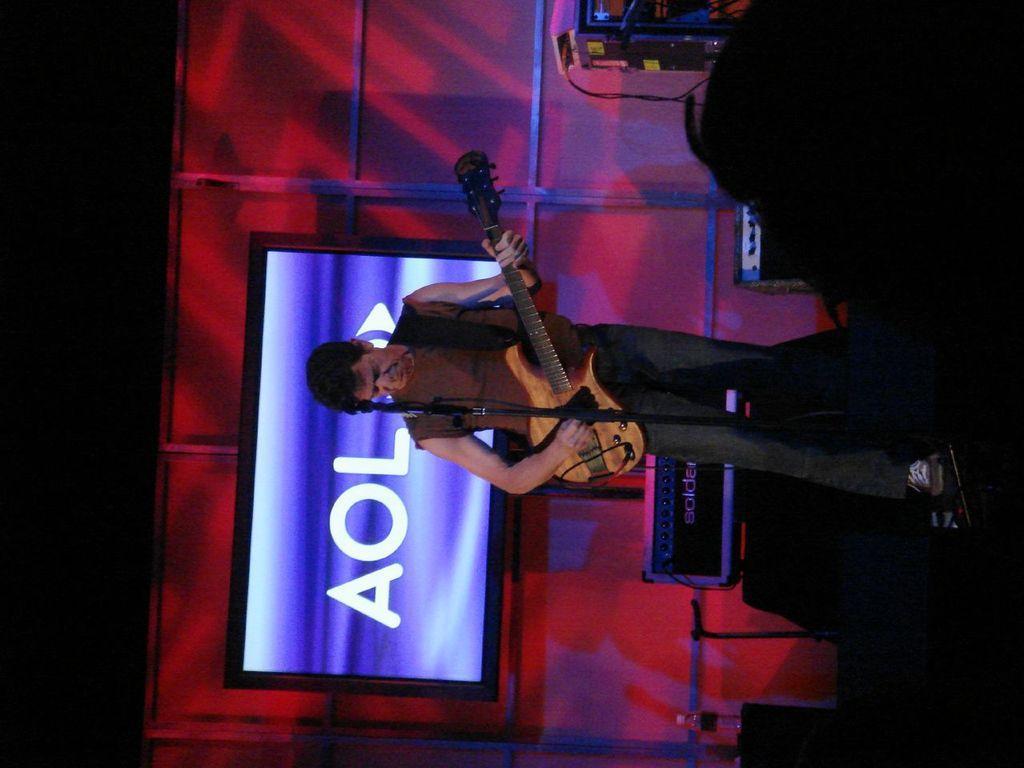In one or two sentences, can you explain what this image depicts? In this picture we can see a man playing guitar in front of a microphone, on the backside of the man there is a digital display. 